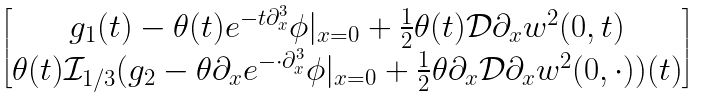Convert formula to latex. <formula><loc_0><loc_0><loc_500><loc_500>\begin{bmatrix} g _ { 1 } ( t ) - \theta ( t ) e ^ { - t \partial _ { x } ^ { 3 } } \phi | _ { x = 0 } + \frac { 1 } { 2 } \theta ( t ) \mathcal { D } \partial _ { x } w ^ { 2 } ( 0 , t ) \\ \theta ( t ) \mathcal { I } _ { 1 / 3 } ( g _ { 2 } - \theta \partial _ { x } e ^ { - \cdot \partial _ { x } ^ { 3 } } \phi | _ { x = 0 } + \frac { 1 } { 2 } \theta \partial _ { x } \mathcal { D } \partial _ { x } w ^ { 2 } ( 0 , \cdot ) ) ( t ) \end{bmatrix}</formula> 